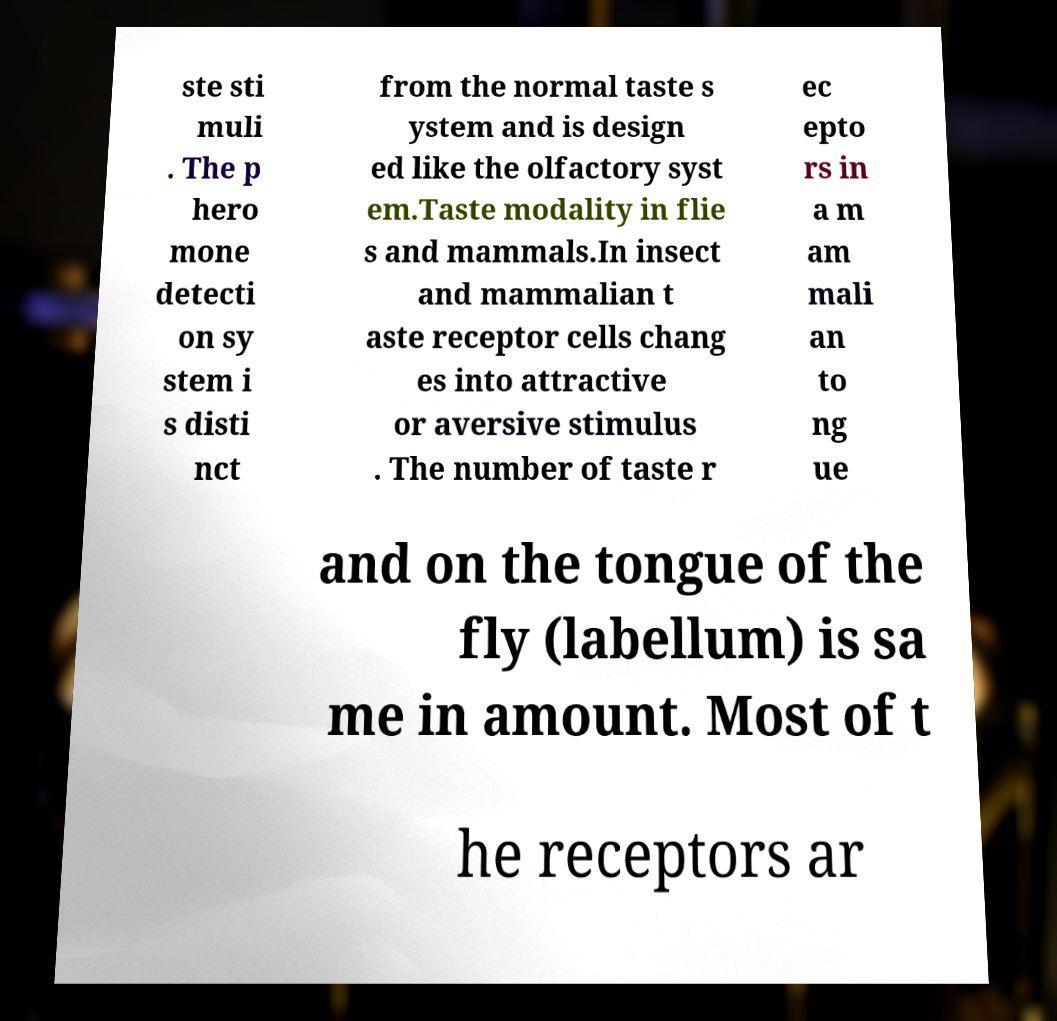Could you extract and type out the text from this image? ste sti muli . The p hero mone detecti on sy stem i s disti nct from the normal taste s ystem and is design ed like the olfactory syst em.Taste modality in flie s and mammals.In insect and mammalian t aste receptor cells chang es into attractive or aversive stimulus . The number of taste r ec epto rs in a m am mali an to ng ue and on the tongue of the fly (labellum) is sa me in amount. Most of t he receptors ar 